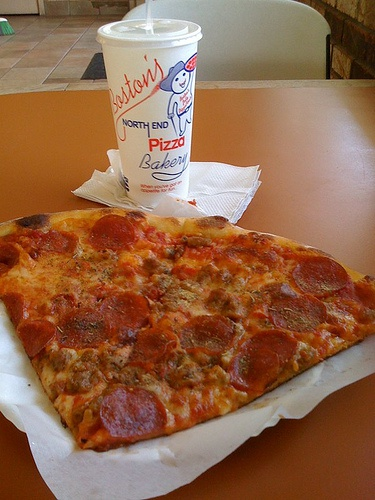Describe the objects in this image and their specific colors. I can see dining table in gray, maroon, brown, and darkgray tones, pizza in gray, maroon, and brown tones, cup in gray, lightgray, tan, and darkgray tones, and chair in gray and darkgray tones in this image. 